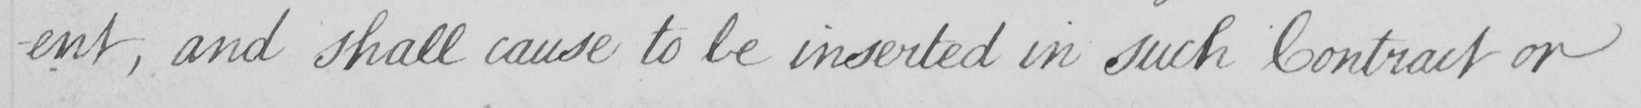Please provide the text content of this handwritten line. -ent , and shall cause to be inserted in such Contract or 